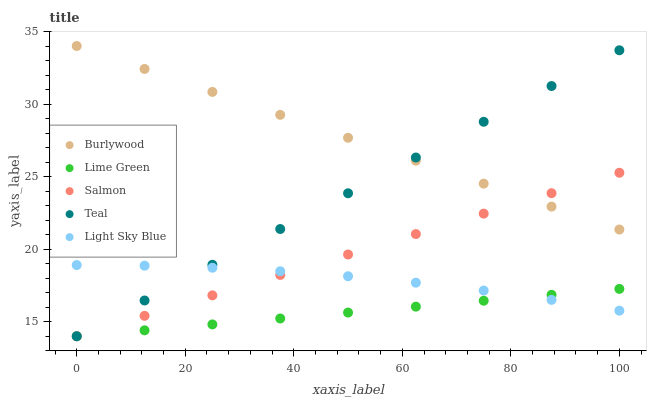Does Lime Green have the minimum area under the curve?
Answer yes or no. Yes. Does Burlywood have the maximum area under the curve?
Answer yes or no. Yes. Does Salmon have the minimum area under the curve?
Answer yes or no. No. Does Salmon have the maximum area under the curve?
Answer yes or no. No. Is Burlywood the smoothest?
Answer yes or no. Yes. Is Light Sky Blue the roughest?
Answer yes or no. Yes. Is Salmon the smoothest?
Answer yes or no. No. Is Salmon the roughest?
Answer yes or no. No. Does Salmon have the lowest value?
Answer yes or no. Yes. Does Light Sky Blue have the lowest value?
Answer yes or no. No. Does Burlywood have the highest value?
Answer yes or no. Yes. Does Salmon have the highest value?
Answer yes or no. No. Is Light Sky Blue less than Burlywood?
Answer yes or no. Yes. Is Burlywood greater than Lime Green?
Answer yes or no. Yes. Does Salmon intersect Light Sky Blue?
Answer yes or no. Yes. Is Salmon less than Light Sky Blue?
Answer yes or no. No. Is Salmon greater than Light Sky Blue?
Answer yes or no. No. Does Light Sky Blue intersect Burlywood?
Answer yes or no. No. 